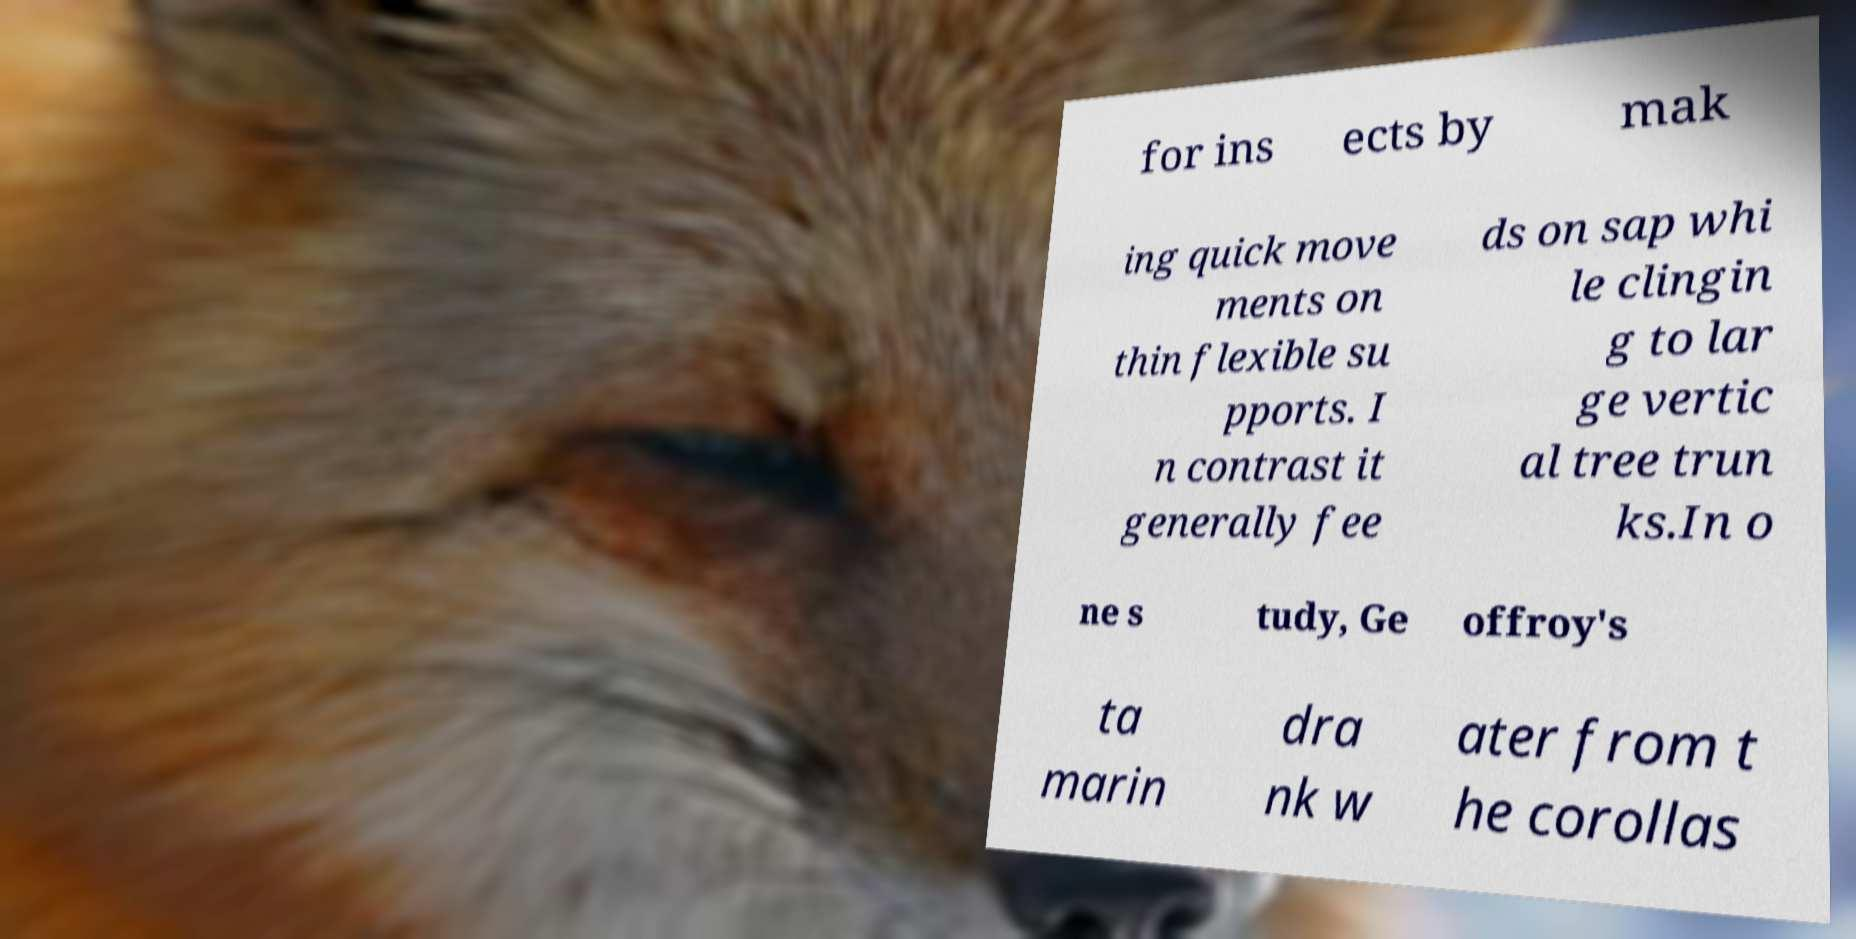Can you read and provide the text displayed in the image?This photo seems to have some interesting text. Can you extract and type it out for me? for ins ects by mak ing quick move ments on thin flexible su pports. I n contrast it generally fee ds on sap whi le clingin g to lar ge vertic al tree trun ks.In o ne s tudy, Ge offroy's ta marin dra nk w ater from t he corollas 